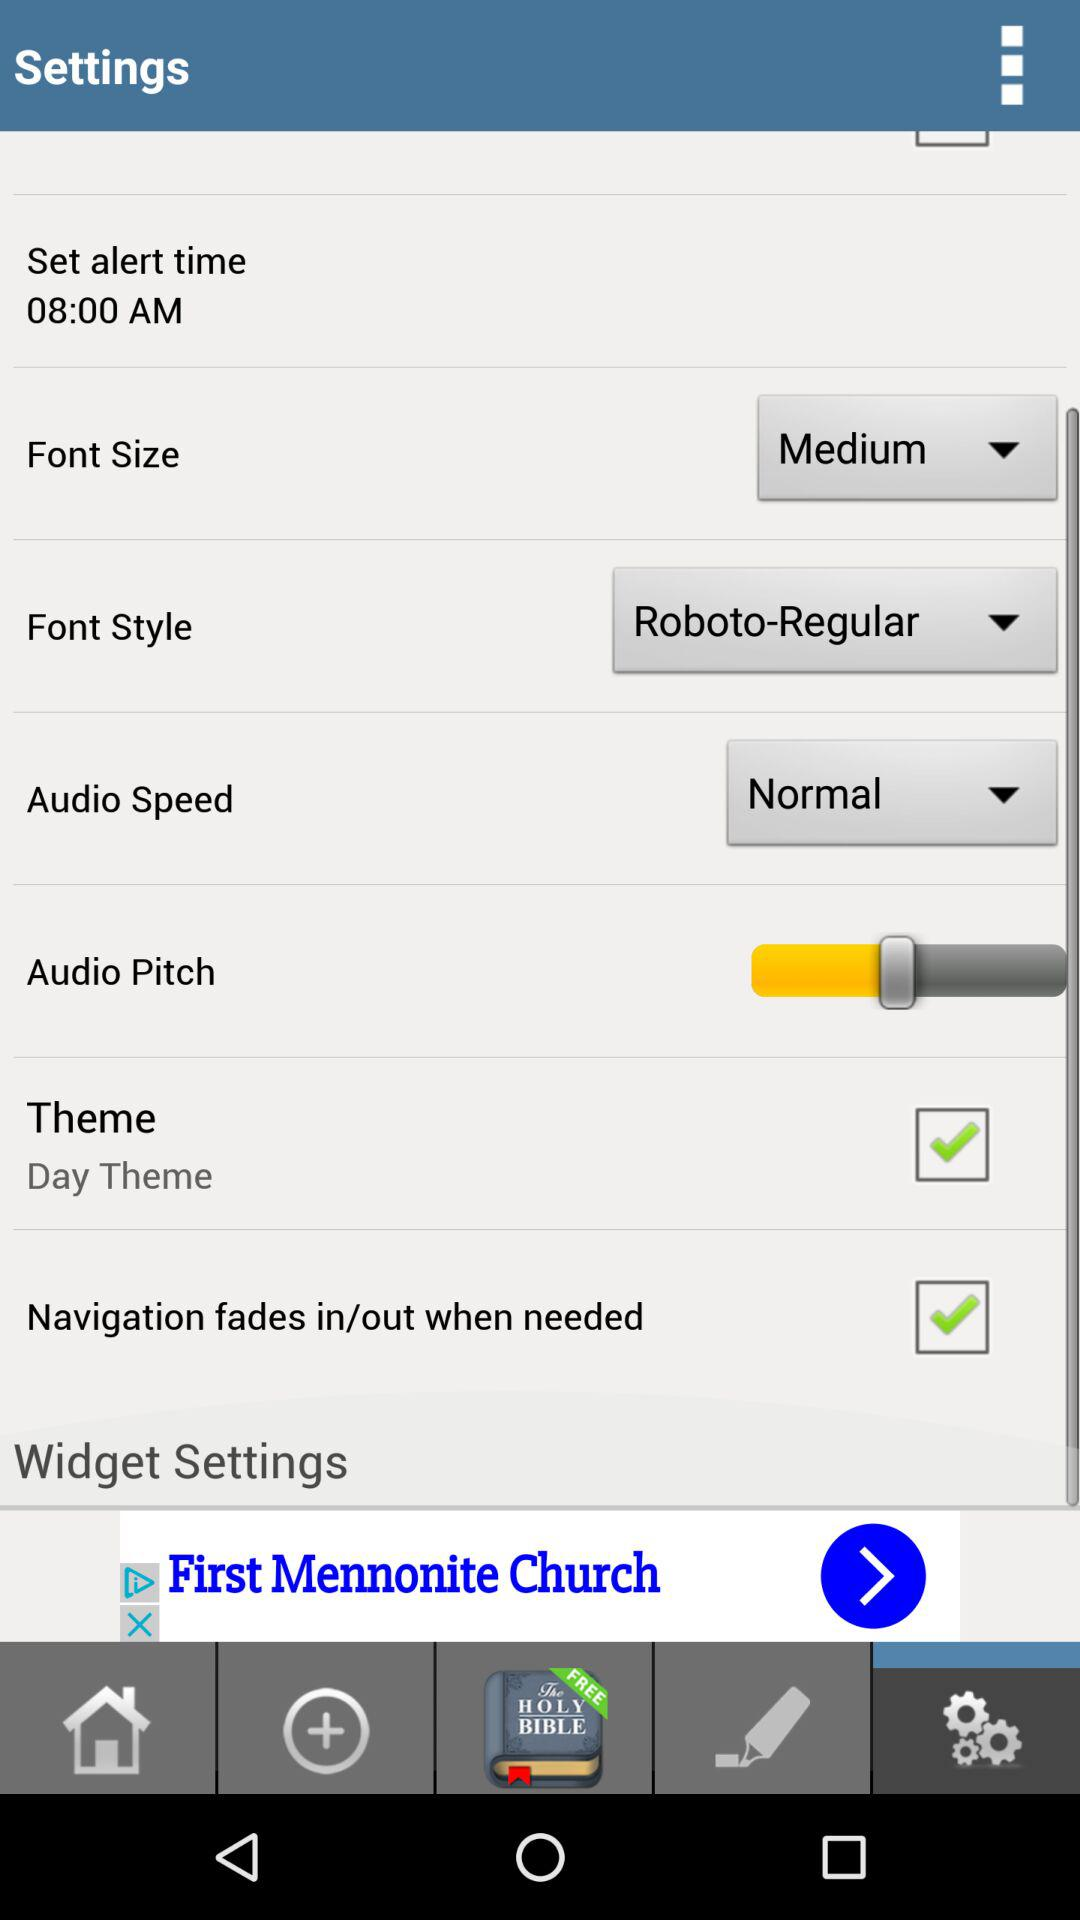How many settings are available for audio?
Answer the question using a single word or phrase. 4 